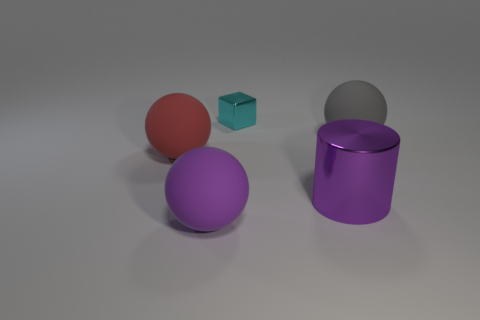If these objects were part of a size comparison exercise, could you rank them from smallest to largest? Absolutely. Beginning with the smallest, the ranking would be the tiny blue cube, followed by the smaller violet sphere, then the red sphere, and finally the purple cylinder, which would be the largest in terms of height. 